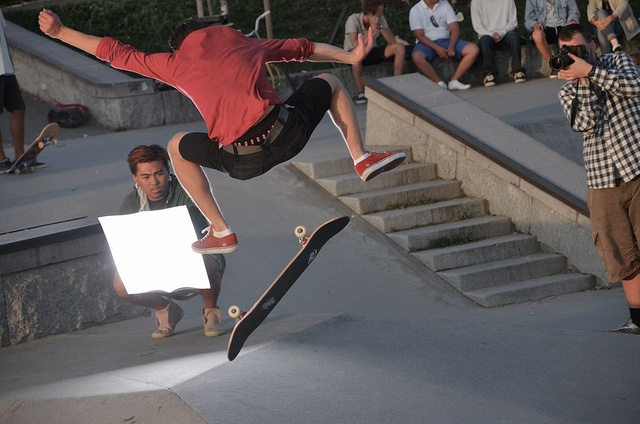Describe the objects in this image and their specific colors. I can see people in black, brown, gray, and maroon tones, people in black, gray, and maroon tones, people in black, gray, and maroon tones, people in black, darkgray, gray, and maroon tones, and skateboard in black, gray, tan, and darkgray tones in this image. 